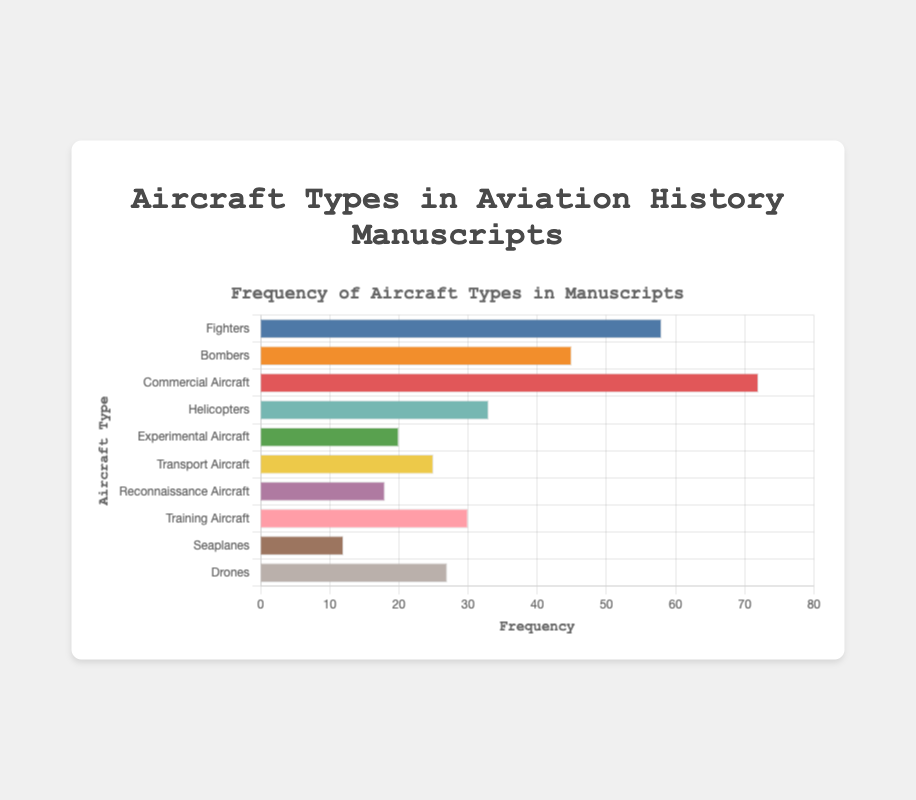Which aircraft type is mentioned most frequently in the manuscripts? To find the most frequently mentioned aircraft type, review the figure for the bar with the greatest length. Here, "Commercial Aircraft" has the highest frequency with a value of 72.
Answer: Commercial Aircraft Which two aircraft types have the least frequency in the manuscripts? Identify the two bars with the shortest lengths in the chart. Here, "Seaplanes" has a frequency of 12, and "Reconnaissance Aircraft" has a frequency of 18.
Answer: Seaplanes and Reconnaissance Aircraft What is the total frequency of Bombers and Fighters combined? Add the frequencies for Bombers (45) and Fighters (58). The total is 45 + 58 = 103.
Answer: 103 Among Helicopters and Training Aircraft, which is mentioned more frequently? Compare the lengths of the bars for Helicopters and Training Aircraft. Helicopters have a frequency of 33, and Training Aircraft have a frequency of 30. Thus, Helicopters are mentioned more frequently.
Answer: Helicopters What is the average frequency of the top 3 most frequently mentioned aircraft types? Identify the top 3 aircraft types by their frequency values: Commercial Aircraft (72), Fighters (58), and Bombers (45). Calculate their average: (72 + 58 + 45) / 3 = 175 / 3 ≈ 58.33.
Answer: 58.33 How does the frequency of Experimental Aircraft compare to Transport Aircraft? Compare the frequency values: Experimental Aircraft (20) and Transport Aircraft (25). Experimental Aircraft have a lower frequency than Transport Aircraft.
Answer: Lower Which aircraft type has the second-lowest frequency? The aircraft type with the second-lowest frequency is found by excluding the one with the lowest frequency (Seaplanes at 12). The next lowest frequency is Reconnaissance Aircraft with 18.
Answer: Reconnaissance Aircraft What is the frequency range (difference between highest and lowest frequencies) in the data? Subtract the frequency of the least frequently mentioned type (Seaplanes at 12) from the most frequently mentioned type (Commercial Aircraft at 72): 72 - 12 = 60.
Answer: 60 